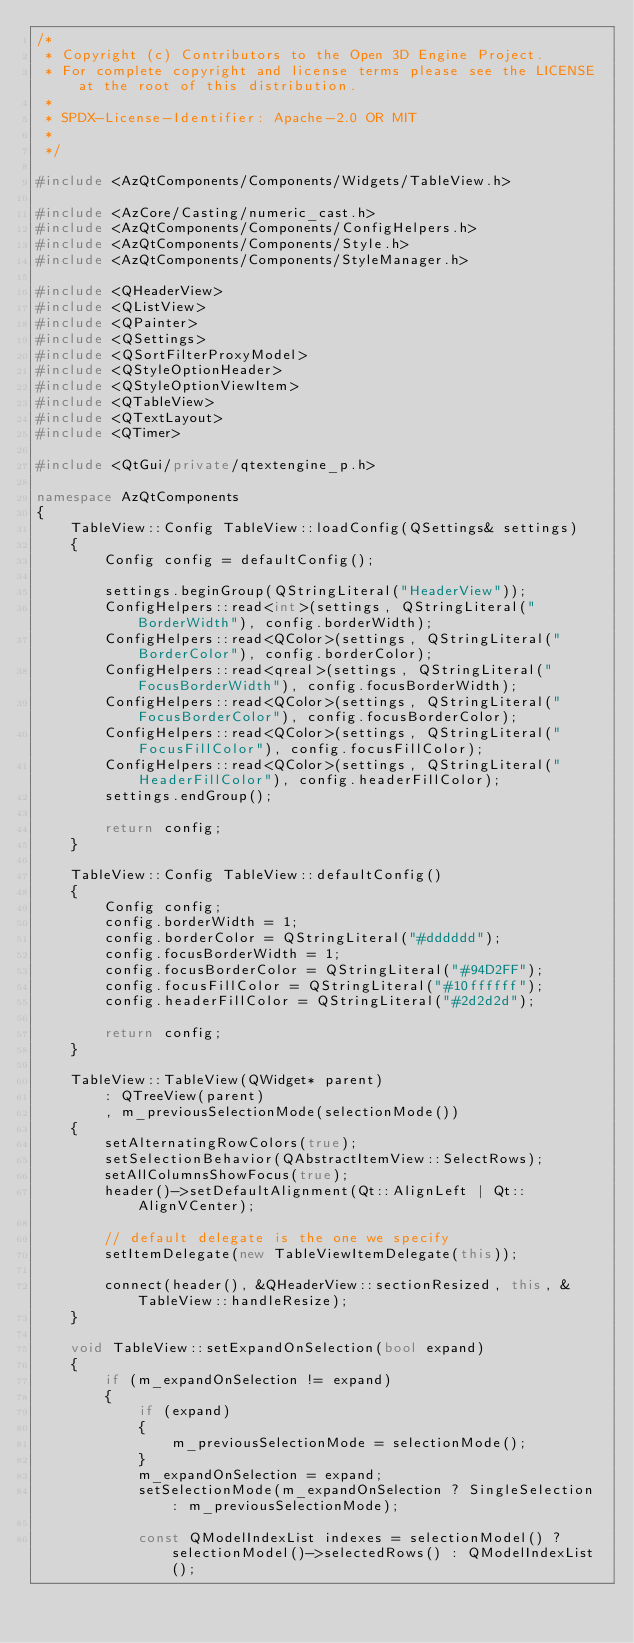<code> <loc_0><loc_0><loc_500><loc_500><_C++_>/*
 * Copyright (c) Contributors to the Open 3D Engine Project.
 * For complete copyright and license terms please see the LICENSE at the root of this distribution.
 *
 * SPDX-License-Identifier: Apache-2.0 OR MIT
 *
 */

#include <AzQtComponents/Components/Widgets/TableView.h>

#include <AzCore/Casting/numeric_cast.h>
#include <AzQtComponents/Components/ConfigHelpers.h>
#include <AzQtComponents/Components/Style.h>
#include <AzQtComponents/Components/StyleManager.h>

#include <QHeaderView>
#include <QListView>
#include <QPainter>
#include <QSettings>
#include <QSortFilterProxyModel>
#include <QStyleOptionHeader>
#include <QStyleOptionViewItem>
#include <QTableView>
#include <QTextLayout>
#include <QTimer>

#include <QtGui/private/qtextengine_p.h>

namespace AzQtComponents
{
    TableView::Config TableView::loadConfig(QSettings& settings)
    {
        Config config = defaultConfig();

        settings.beginGroup(QStringLiteral("HeaderView"));
        ConfigHelpers::read<int>(settings, QStringLiteral("BorderWidth"), config.borderWidth);
        ConfigHelpers::read<QColor>(settings, QStringLiteral("BorderColor"), config.borderColor);
        ConfigHelpers::read<qreal>(settings, QStringLiteral("FocusBorderWidth"), config.focusBorderWidth);
        ConfigHelpers::read<QColor>(settings, QStringLiteral("FocusBorderColor"), config.focusBorderColor);
        ConfigHelpers::read<QColor>(settings, QStringLiteral("FocusFillColor"), config.focusFillColor);
        ConfigHelpers::read<QColor>(settings, QStringLiteral("HeaderFillColor"), config.headerFillColor);
        settings.endGroup();

        return config;
    }

    TableView::Config TableView::defaultConfig()
    {
        Config config;
        config.borderWidth = 1;
        config.borderColor = QStringLiteral("#dddddd");
        config.focusBorderWidth = 1;
        config.focusBorderColor = QStringLiteral("#94D2FF");
        config.focusFillColor = QStringLiteral("#10ffffff");
        config.headerFillColor = QStringLiteral("#2d2d2d");

        return config;
    }

    TableView::TableView(QWidget* parent)
        : QTreeView(parent)
        , m_previousSelectionMode(selectionMode())
    {
        setAlternatingRowColors(true);
        setSelectionBehavior(QAbstractItemView::SelectRows);
        setAllColumnsShowFocus(true);
        header()->setDefaultAlignment(Qt::AlignLeft | Qt::AlignVCenter);

        // default delegate is the one we specify
        setItemDelegate(new TableViewItemDelegate(this));

        connect(header(), &QHeaderView::sectionResized, this, &TableView::handleResize);
    }

    void TableView::setExpandOnSelection(bool expand)
    {
        if (m_expandOnSelection != expand)
        {
            if (expand)
            {
                m_previousSelectionMode = selectionMode();
            }
            m_expandOnSelection = expand;
            setSelectionMode(m_expandOnSelection ? SingleSelection : m_previousSelectionMode);

            const QModelIndexList indexes = selectionModel() ? selectionModel()->selectedRows() : QModelIndexList();</code> 